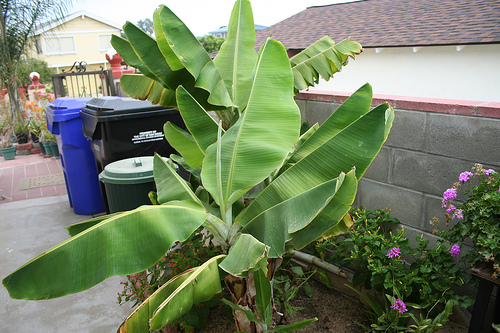<image>
Can you confirm if the brick is to the right of the stem? No. The brick is not to the right of the stem. The horizontal positioning shows a different relationship. 